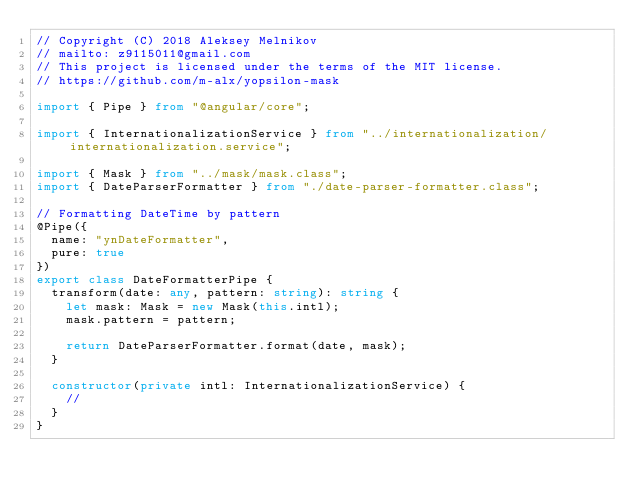<code> <loc_0><loc_0><loc_500><loc_500><_TypeScript_>// Copyright (C) 2018 Aleksey Melnikov
// mailto: z9115011@gmail.com
// This project is licensed under the terms of the MIT license.
// https://github.com/m-alx/yopsilon-mask

import { Pipe } from "@angular/core";

import { InternationalizationService } from "../internationalization/internationalization.service";

import { Mask } from "../mask/mask.class";
import { DateParserFormatter } from "./date-parser-formatter.class";

// Formatting DateTime by pattern
@Pipe({
  name: "ynDateFormatter",
  pure: true
})
export class DateFormatterPipe {
  transform(date: any, pattern: string): string {
    let mask: Mask = new Mask(this.intl);
    mask.pattern = pattern;

    return DateParserFormatter.format(date, mask);
  }

  constructor(private intl: InternationalizationService) {
    //
  }
}
</code> 